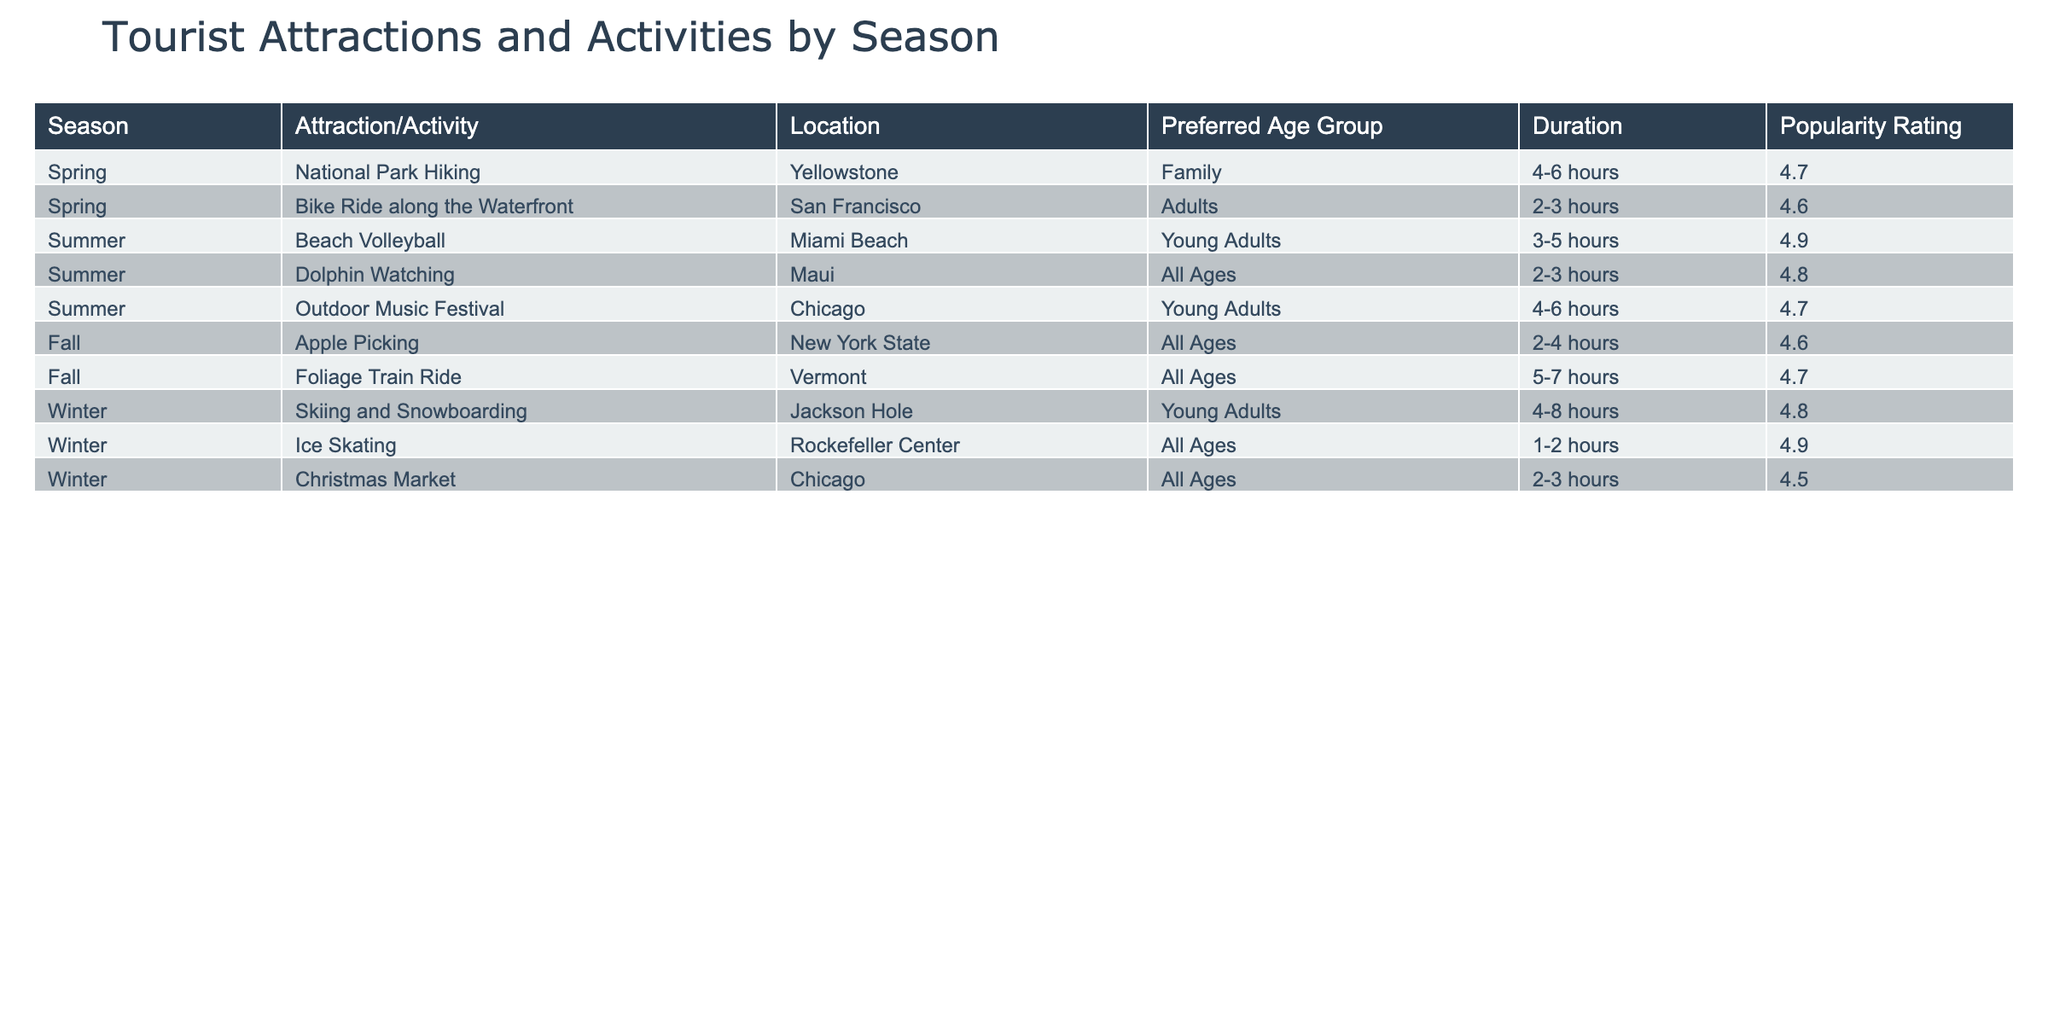What activity has the highest popularity rating in the summer? The table shows that "Beach Volleyball" has a popularity rating of 4.9, which is the highest in the summer season compared to other activities listed under that season.
Answer: Beach Volleyball What is the duration of the "Foliage Train Ride"? According to the table, the "Foliage Train Ride" takes between 5-7 hours, as specified in the duration column for the fall season.
Answer: 5-7 hours Is there an activity suitable for all ages during winter? The table indicates that both "Ice Skating" and "Christmas Market" are activities that can be enjoyed by all ages during the winter season.
Answer: Yes What is the most popular activity in fall and how does its rating compare to the least popular activity in winter? "Foliage Train Ride" has a popularity rating of 4.7, which is the most popular in the fall season. In contrast, "Christmas Market" has the lowest rating in winter at 4.5. The difference in ratings is 4.7 - 4.5 = 0.2.
Answer: 4.7, 0.2 Which age group prefers "Dolphin Watching"? The table specifies that "Dolphin Watching" is preferred by "All Ages," as noted under the age group column in the summer section.
Answer: All Ages Calculate the average popularity rating for activities available in spring. The activities in spring are "National Park Hiking" (4.7) and "Bike Ride along the Waterfront" (4.6). The average can be calculated as (4.7 + 4.6) / 2 = 4.65.
Answer: 4.65 What is the only activity in winter that has a duration of less than 3 hours? The "Ice Skating" activity has a duration of 1-2 hours, making it the only winter activity that fits this criterion based on the table data.
Answer: Ice Skating How many activities are there in the summer compared to fall? In the table, there are three activities (Beach Volleyball, Dolphin Watching, Outdoor Music Festival) listed for the summer and two activities (Apple Picking, Foliage Train Ride) for the fall. Therefore, the summer has one more activity than the fall.
Answer: 1 more activity in summer Which season has the most diverse range of preferred age groups based on the activities listed? The summer season offers activities for "Young Adults" (Beach Volleyball and Outdoor Music Festival) as well as "All Ages" (Dolphin Watching), making it more diverse in terms of preferred age groups compared to the other seasons. This indicates a broader appeal for different age demographics.
Answer: Summer Which activity has the longest duration across all seasons? The "Foliage Train Ride" in fall has the longest estimated duration of 5-7 hours, making it the activity with the greatest time requirement among all options provided in the table.
Answer: Foliage Train Ride 